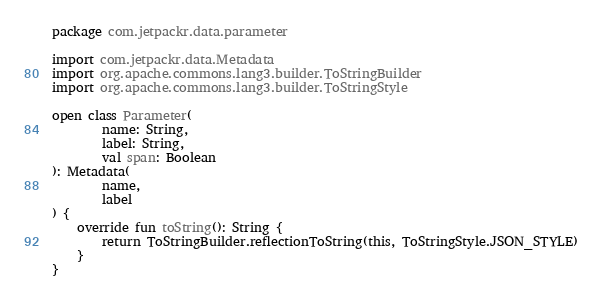<code> <loc_0><loc_0><loc_500><loc_500><_Kotlin_>package com.jetpackr.data.parameter

import com.jetpackr.data.Metadata
import org.apache.commons.lang3.builder.ToStringBuilder
import org.apache.commons.lang3.builder.ToStringStyle

open class Parameter(
        name: String,
        label: String,
        val span: Boolean
): Metadata(
        name,
        label
) {
    override fun toString(): String {
        return ToStringBuilder.reflectionToString(this, ToStringStyle.JSON_STYLE)
    }
}</code> 